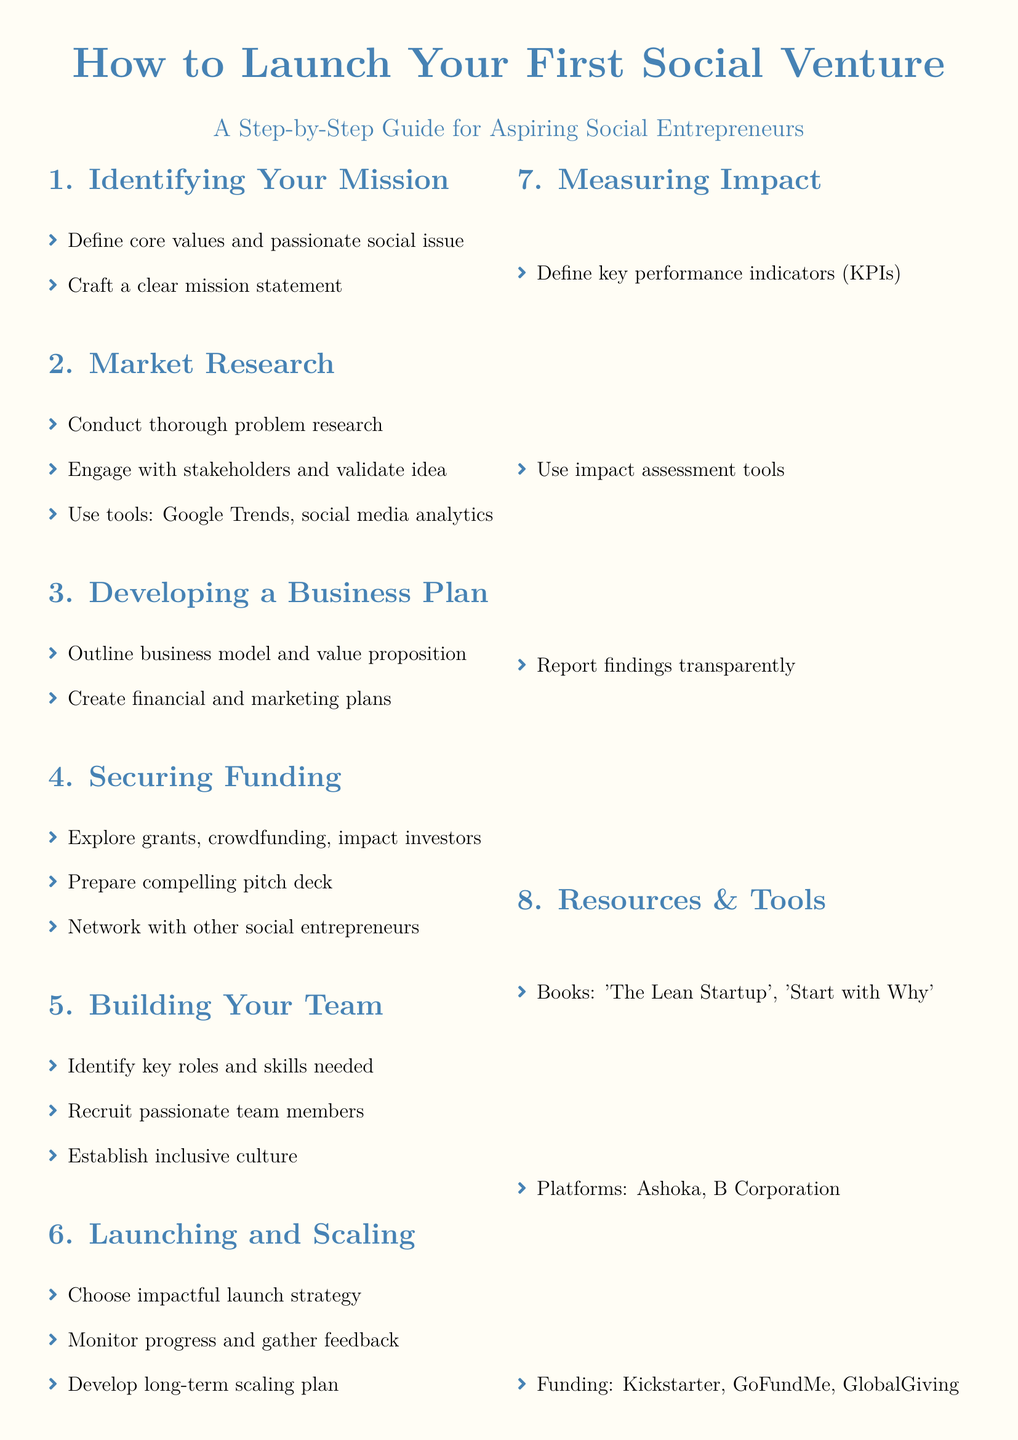What is the first step in launching a social venture? The first step is identifying your mission, which includes defining core values and a social issue.
Answer: Identifying Your Mission What is essential for market research? Engaging with stakeholders and validating the idea is essential for conducting thorough market research.
Answer: Engage with stakeholders and validate idea Which book is recommended in the resources section? The document includes recommendations for books that are helpful for social entrepreneurs. One of them is 'The Lean Startup'.
Answer: The Lean Startup What should a compelling pitch deck include? The pitch deck should be prepared to secure funding and compel investors.
Answer: Compelling pitch deck How many key areas are identified in the guide? The guide outlines eight key areas necessary for launching a social venture.
Answer: Eight What is a key element in building your team? Identifying key roles and the necessary skills is crucial in building a successful team.
Answer: Key roles and skills needed What platforms are mentioned under resources and tools? The document lists various platforms that support social entrepreneurs, including Ashoka and B Corporation.
Answer: Ashoka, B Corporation What is the final step in the guide? The final step focuses on measuring impact, wherein key performance indicators are defined.
Answer: Measuring Impact 